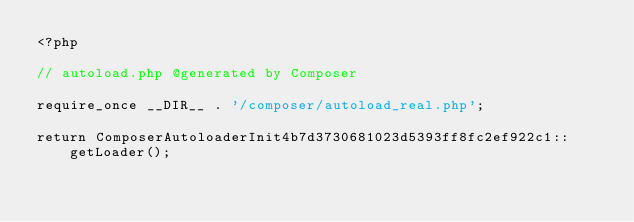<code> <loc_0><loc_0><loc_500><loc_500><_PHP_><?php

// autoload.php @generated by Composer

require_once __DIR__ . '/composer/autoload_real.php';

return ComposerAutoloaderInit4b7d3730681023d5393ff8fc2ef922c1::getLoader();
</code> 